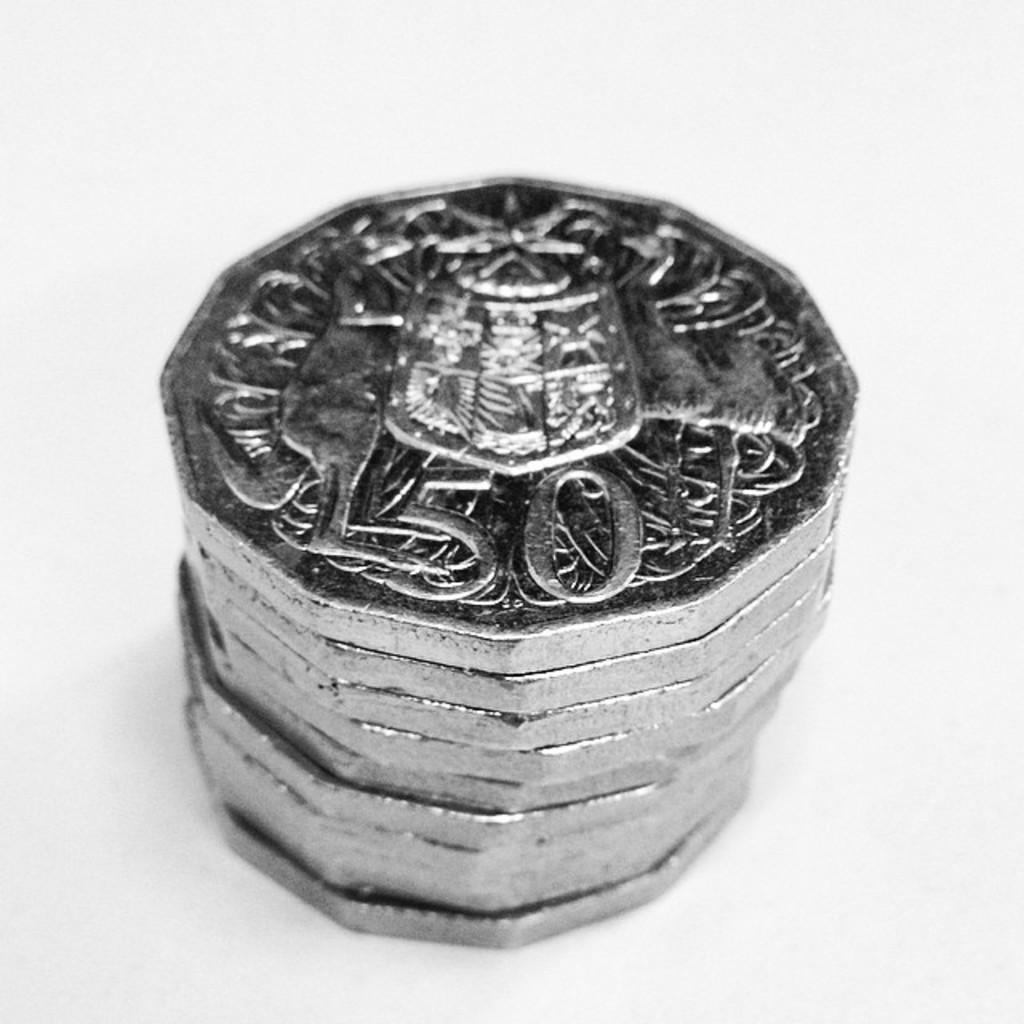<image>
Offer a succinct explanation of the picture presented. a stack of silver coins, with facets instead of turns, and the number fifty. 